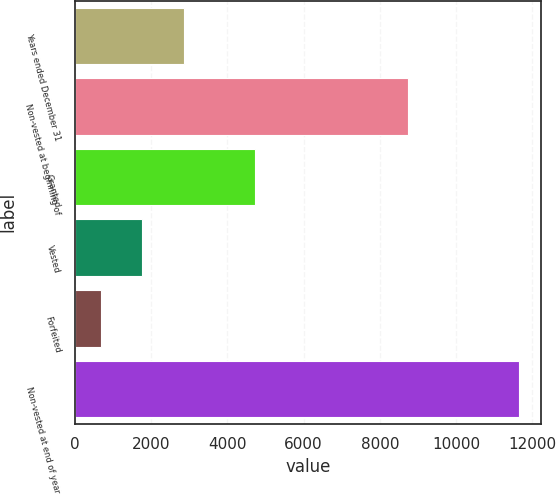Convert chart to OTSL. <chart><loc_0><loc_0><loc_500><loc_500><bar_chart><fcel>Years ended December 31<fcel>Non-vested at beginning of<fcel>Granted<fcel>Vested<fcel>Forfeited<fcel>Non-vested at end of year<nl><fcel>2871.4<fcel>8738<fcel>4727<fcel>1775.2<fcel>679<fcel>11641<nl></chart> 